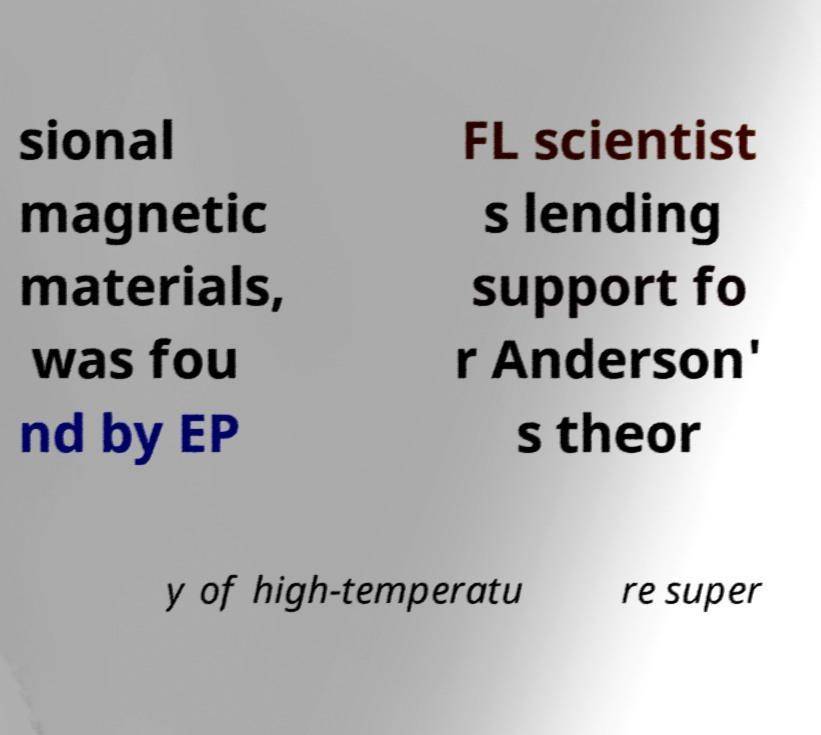For documentation purposes, I need the text within this image transcribed. Could you provide that? sional magnetic materials, was fou nd by EP FL scientist s lending support fo r Anderson' s theor y of high-temperatu re super 